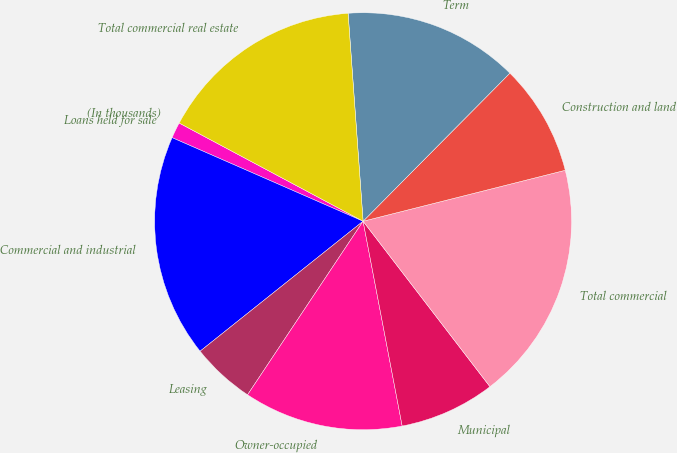Convert chart to OTSL. <chart><loc_0><loc_0><loc_500><loc_500><pie_chart><fcel>(In thousands)<fcel>Loans held for sale<fcel>Commercial and industrial<fcel>Leasing<fcel>Owner-occupied<fcel>Municipal<fcel>Total commercial<fcel>Construction and land<fcel>Term<fcel>Total commercial real estate<nl><fcel>0.0%<fcel>1.24%<fcel>17.28%<fcel>4.94%<fcel>12.35%<fcel>7.41%<fcel>18.52%<fcel>8.64%<fcel>13.58%<fcel>16.05%<nl></chart> 